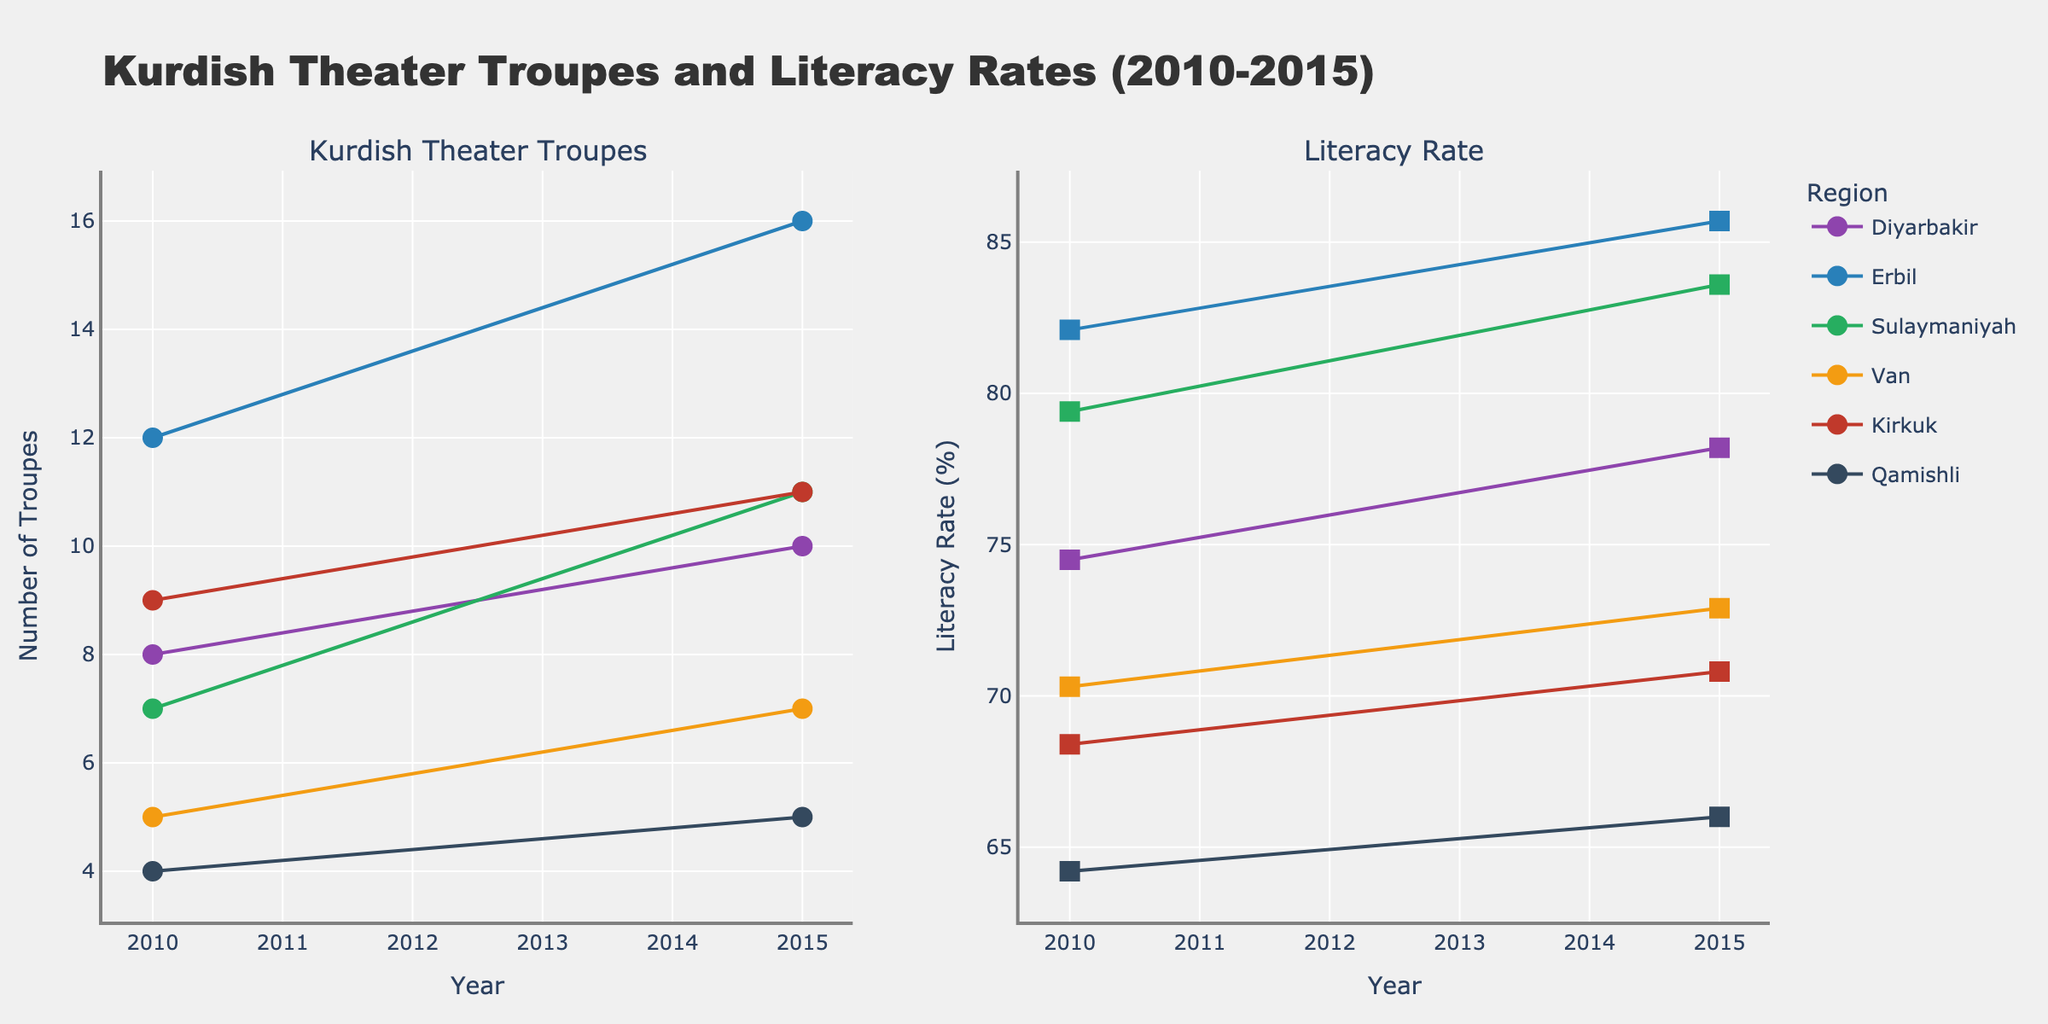What's the title of the plot? The plot's title is written at the top of the figure. It reads "Kurdish Theater Troupes and Literacy Rates (2010-2015)".
Answer: Kurdish Theater Troupes and Literacy Rates (2010-2015) What are the x-axis labels for the two plots? The x-axis labels are the same for both plots and are shown at the bottom of each subplot. They indicate the years represented in the data.
Answer: Year Which region had the highest number of theater troupes in 2010? The figure shows the number of theater troupes for each region in 2010. By observing the values, Erbil had the highest number with 12 troupes.
Answer: Erbil What is the trend in the number of Kurdish theater troupes in Sulaymaniyah from 2010 to 2015? The trend can be identified by comparing the data points for 2010 and 2015 for Sulaymaniyah. The number increased from 7 to 11, indicating a positive trend.
Answer: Increasing Compare the literacy rate in Diyarbakir and Erbil in 2015. Which region had a higher literacy rate? By checking the literacy rate values for both regions in the 2015 plot, Erbil had a higher literacy rate at 85.7 compared to Diyarbakir's 78.2.
Answer: Erbil What's the difference in the number of theater troupes in Kirkuk between 2010 and 2015? To find the difference, subtract the 2010 value (9) from the 2015 value (11). The difference is 2.
Answer: 2 How did the literacy rate in Van change from 2010 to 2015? Observing the literacy rate in Van for the years 2010 and 2015 in the plot, it increased from 70.3% to 72.9%.
Answer: Increased What region experienced the smallest increase in the number of Kurdish theater troupes between 2010 and 2015? By comparing the differences in the number of troupes for each region between 2010 and 2015, Qamishli experienced the smallest increase, from 4 to 5 troupes.
Answer: Qamishli Is there a region where the number of theater troupes and literacy rate both increased between 2010 and 2015? Checking each region's data points for both theater troupes and literacy rates, Diyarbakir, Erbil, Sulaymaniyah, Van, Kirkuk, and Qamishli all show increases in both measures.
Answer: Yes Compare the increase in literacy rates in Van and Qamishli from 2010 to 2015. Which region had a higher increase? Calculate the increase in literacy rates for both regions. Van increased by 2.6% (72.9 - 70.3), and Qamishli increased by 1.8% (66.0 - 64.2). Van had a higher increase.
Answer: Van 